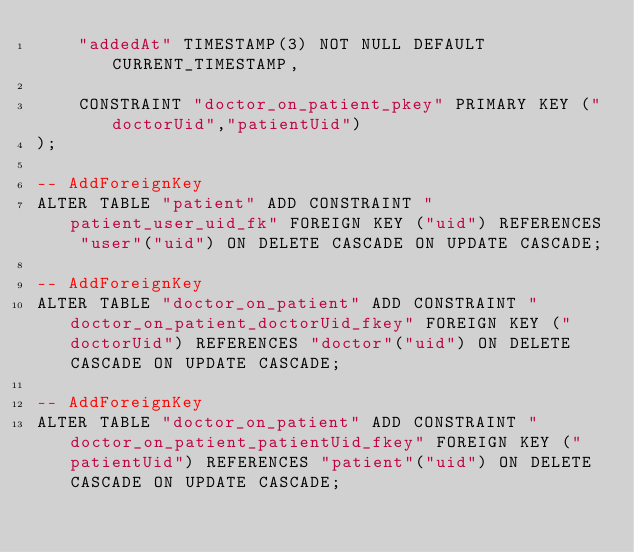<code> <loc_0><loc_0><loc_500><loc_500><_SQL_>    "addedAt" TIMESTAMP(3) NOT NULL DEFAULT CURRENT_TIMESTAMP,

    CONSTRAINT "doctor_on_patient_pkey" PRIMARY KEY ("doctorUid","patientUid")
);

-- AddForeignKey
ALTER TABLE "patient" ADD CONSTRAINT "patient_user_uid_fk" FOREIGN KEY ("uid") REFERENCES "user"("uid") ON DELETE CASCADE ON UPDATE CASCADE;

-- AddForeignKey
ALTER TABLE "doctor_on_patient" ADD CONSTRAINT "doctor_on_patient_doctorUid_fkey" FOREIGN KEY ("doctorUid") REFERENCES "doctor"("uid") ON DELETE CASCADE ON UPDATE CASCADE;

-- AddForeignKey
ALTER TABLE "doctor_on_patient" ADD CONSTRAINT "doctor_on_patient_patientUid_fkey" FOREIGN KEY ("patientUid") REFERENCES "patient"("uid") ON DELETE CASCADE ON UPDATE CASCADE;
</code> 